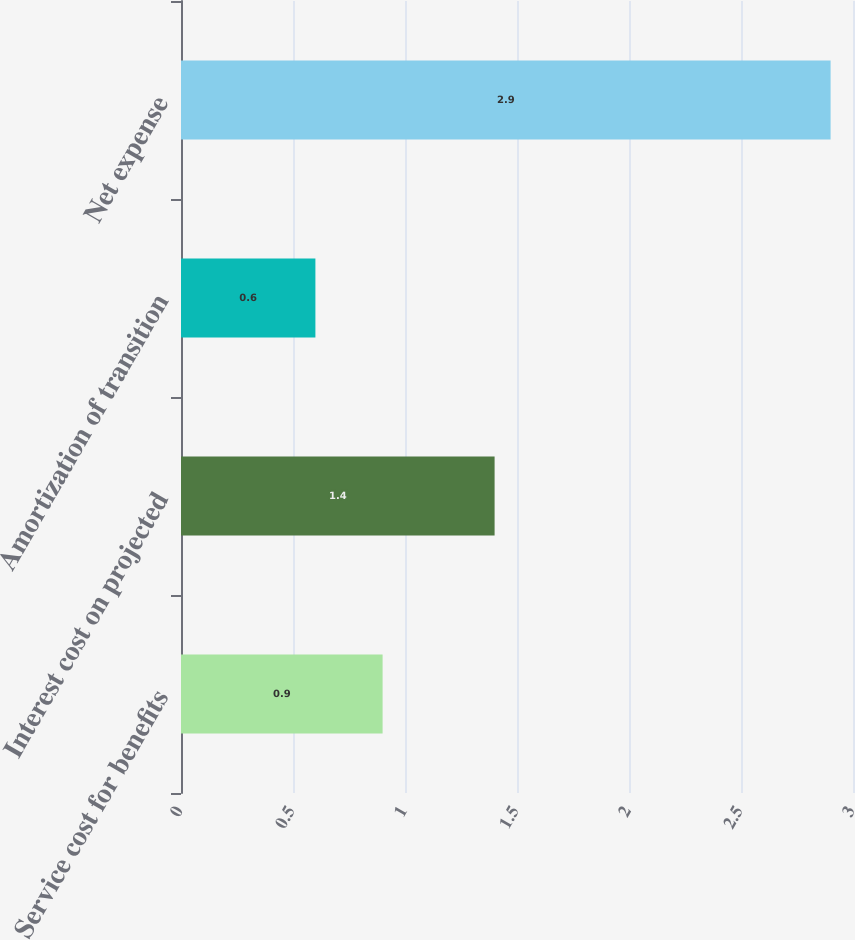Convert chart to OTSL. <chart><loc_0><loc_0><loc_500><loc_500><bar_chart><fcel>Service cost for benefits<fcel>Interest cost on projected<fcel>Amortization of transition<fcel>Net expense<nl><fcel>0.9<fcel>1.4<fcel>0.6<fcel>2.9<nl></chart> 